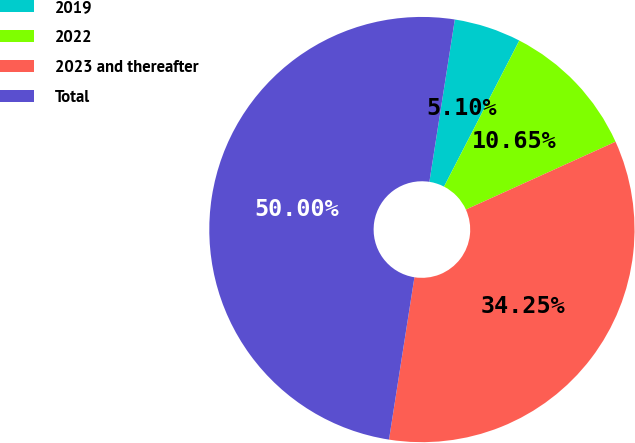Convert chart. <chart><loc_0><loc_0><loc_500><loc_500><pie_chart><fcel>2019<fcel>2022<fcel>2023 and thereafter<fcel>Total<nl><fcel>5.1%<fcel>10.65%<fcel>34.25%<fcel>50.0%<nl></chart> 